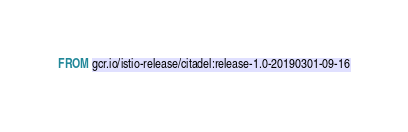<code> <loc_0><loc_0><loc_500><loc_500><_Dockerfile_>FROM gcr.io/istio-release/citadel:release-1.0-20190301-09-16
</code> 